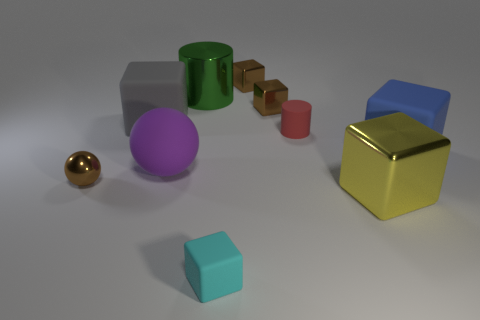Subtract all green cylinders. How many cylinders are left? 1 Subtract all balls. How many objects are left? 8 Add 5 small red rubber cylinders. How many small red rubber cylinders exist? 6 Subtract all gray blocks. How many blocks are left? 5 Subtract 0 purple cubes. How many objects are left? 10 Subtract 1 cylinders. How many cylinders are left? 1 Subtract all gray cubes. Subtract all yellow cylinders. How many cubes are left? 5 Subtract all red blocks. How many red balls are left? 0 Subtract all tiny blue cylinders. Subtract all big things. How many objects are left? 5 Add 5 green metallic things. How many green metallic things are left? 6 